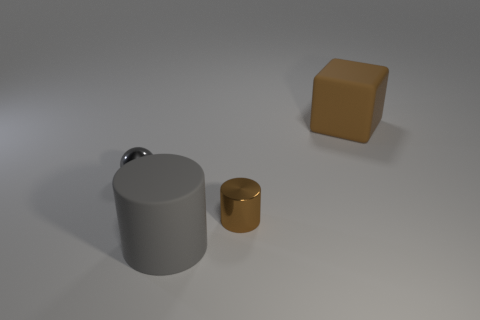Add 1 brown shiny cylinders. How many objects exist? 5 Subtract all spheres. How many objects are left? 3 Add 1 small metallic cylinders. How many small metallic cylinders are left? 2 Add 3 cylinders. How many cylinders exist? 5 Subtract 0 brown balls. How many objects are left? 4 Subtract all large red metallic blocks. Subtract all gray cylinders. How many objects are left? 3 